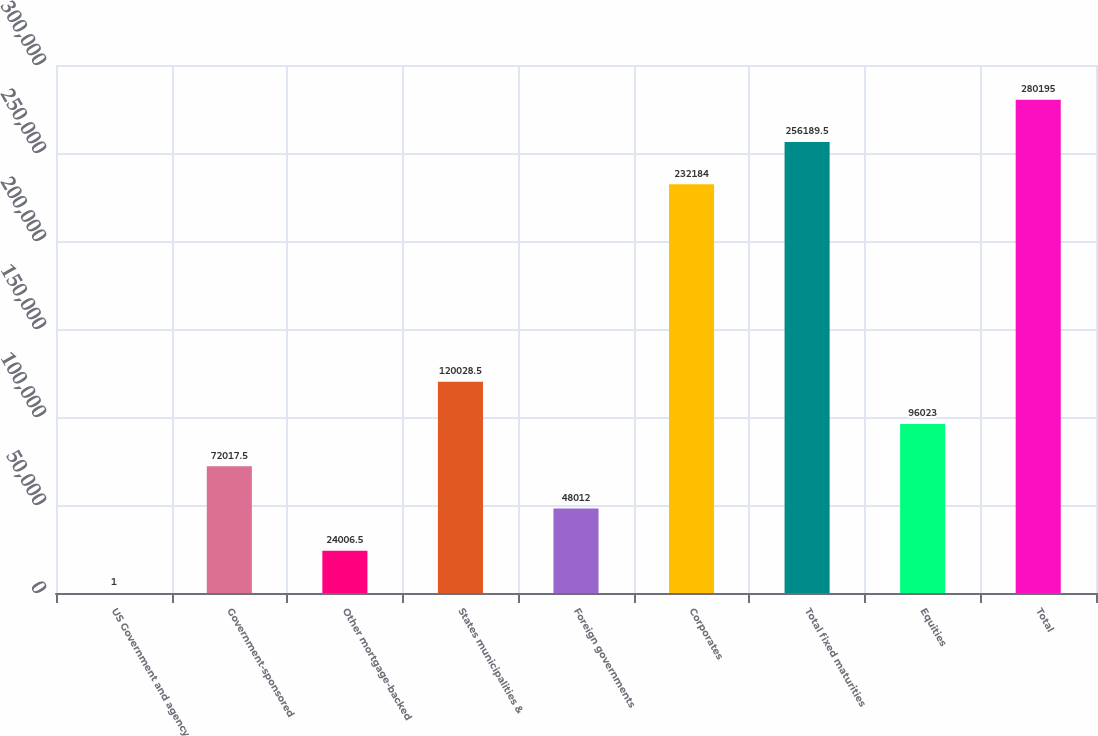Convert chart to OTSL. <chart><loc_0><loc_0><loc_500><loc_500><bar_chart><fcel>US Government and agency<fcel>Government-sponsored<fcel>Other mortgage-backed<fcel>States municipalities &<fcel>Foreign governments<fcel>Corporates<fcel>Total fixed maturities<fcel>Equities<fcel>Total<nl><fcel>1<fcel>72017.5<fcel>24006.5<fcel>120028<fcel>48012<fcel>232184<fcel>256190<fcel>96023<fcel>280195<nl></chart> 